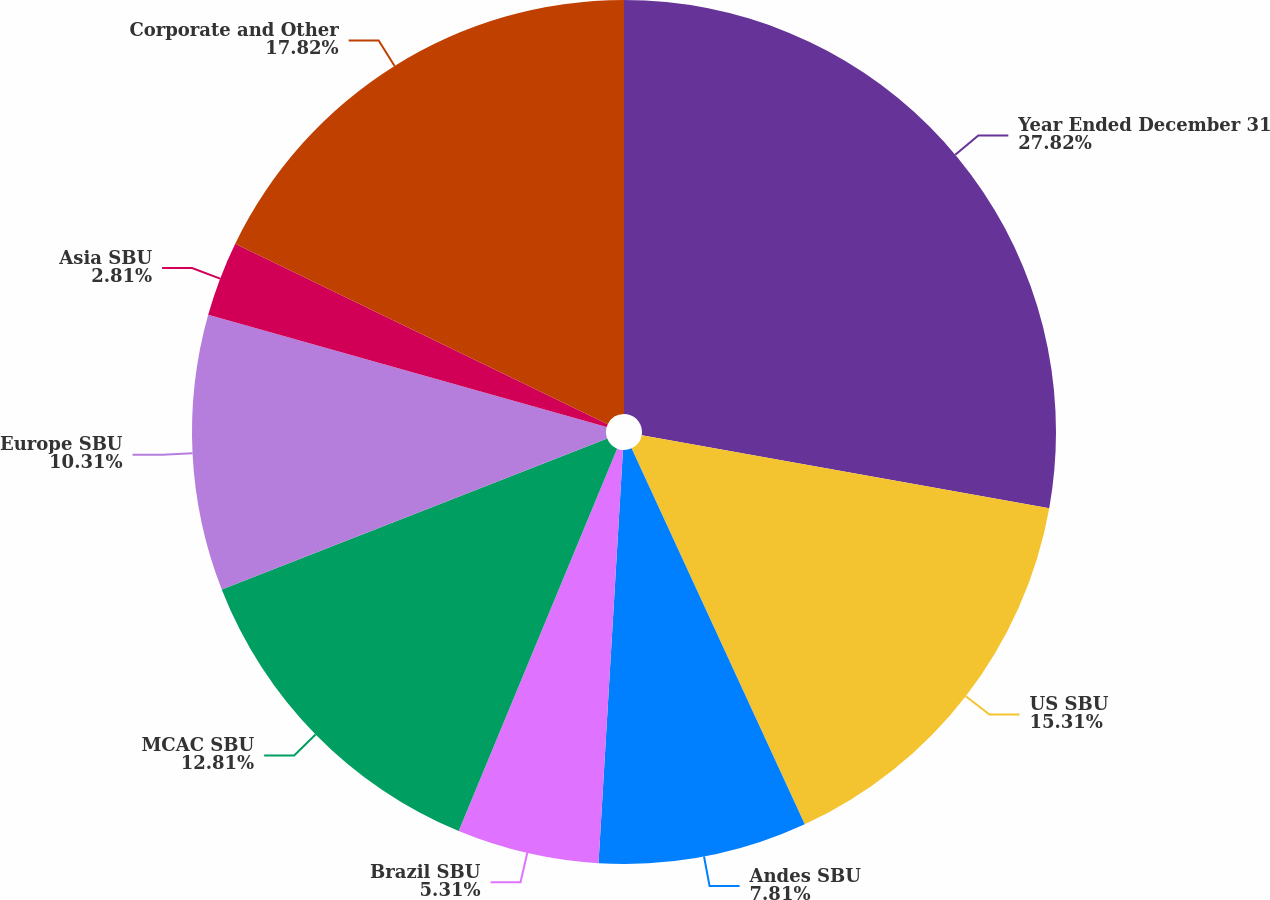<chart> <loc_0><loc_0><loc_500><loc_500><pie_chart><fcel>Year Ended December 31<fcel>US SBU<fcel>Andes SBU<fcel>Brazil SBU<fcel>MCAC SBU<fcel>Europe SBU<fcel>Asia SBU<fcel>Corporate and Other<nl><fcel>27.82%<fcel>15.31%<fcel>7.81%<fcel>5.31%<fcel>12.81%<fcel>10.31%<fcel>2.81%<fcel>17.82%<nl></chart> 